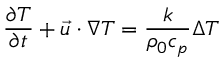Convert formula to latex. <formula><loc_0><loc_0><loc_500><loc_500>\frac { \partial T } { \partial t } + \vec { u } \cdot \nabla T = \frac { k } { \rho _ { 0 } c _ { p } } \Delta T</formula> 